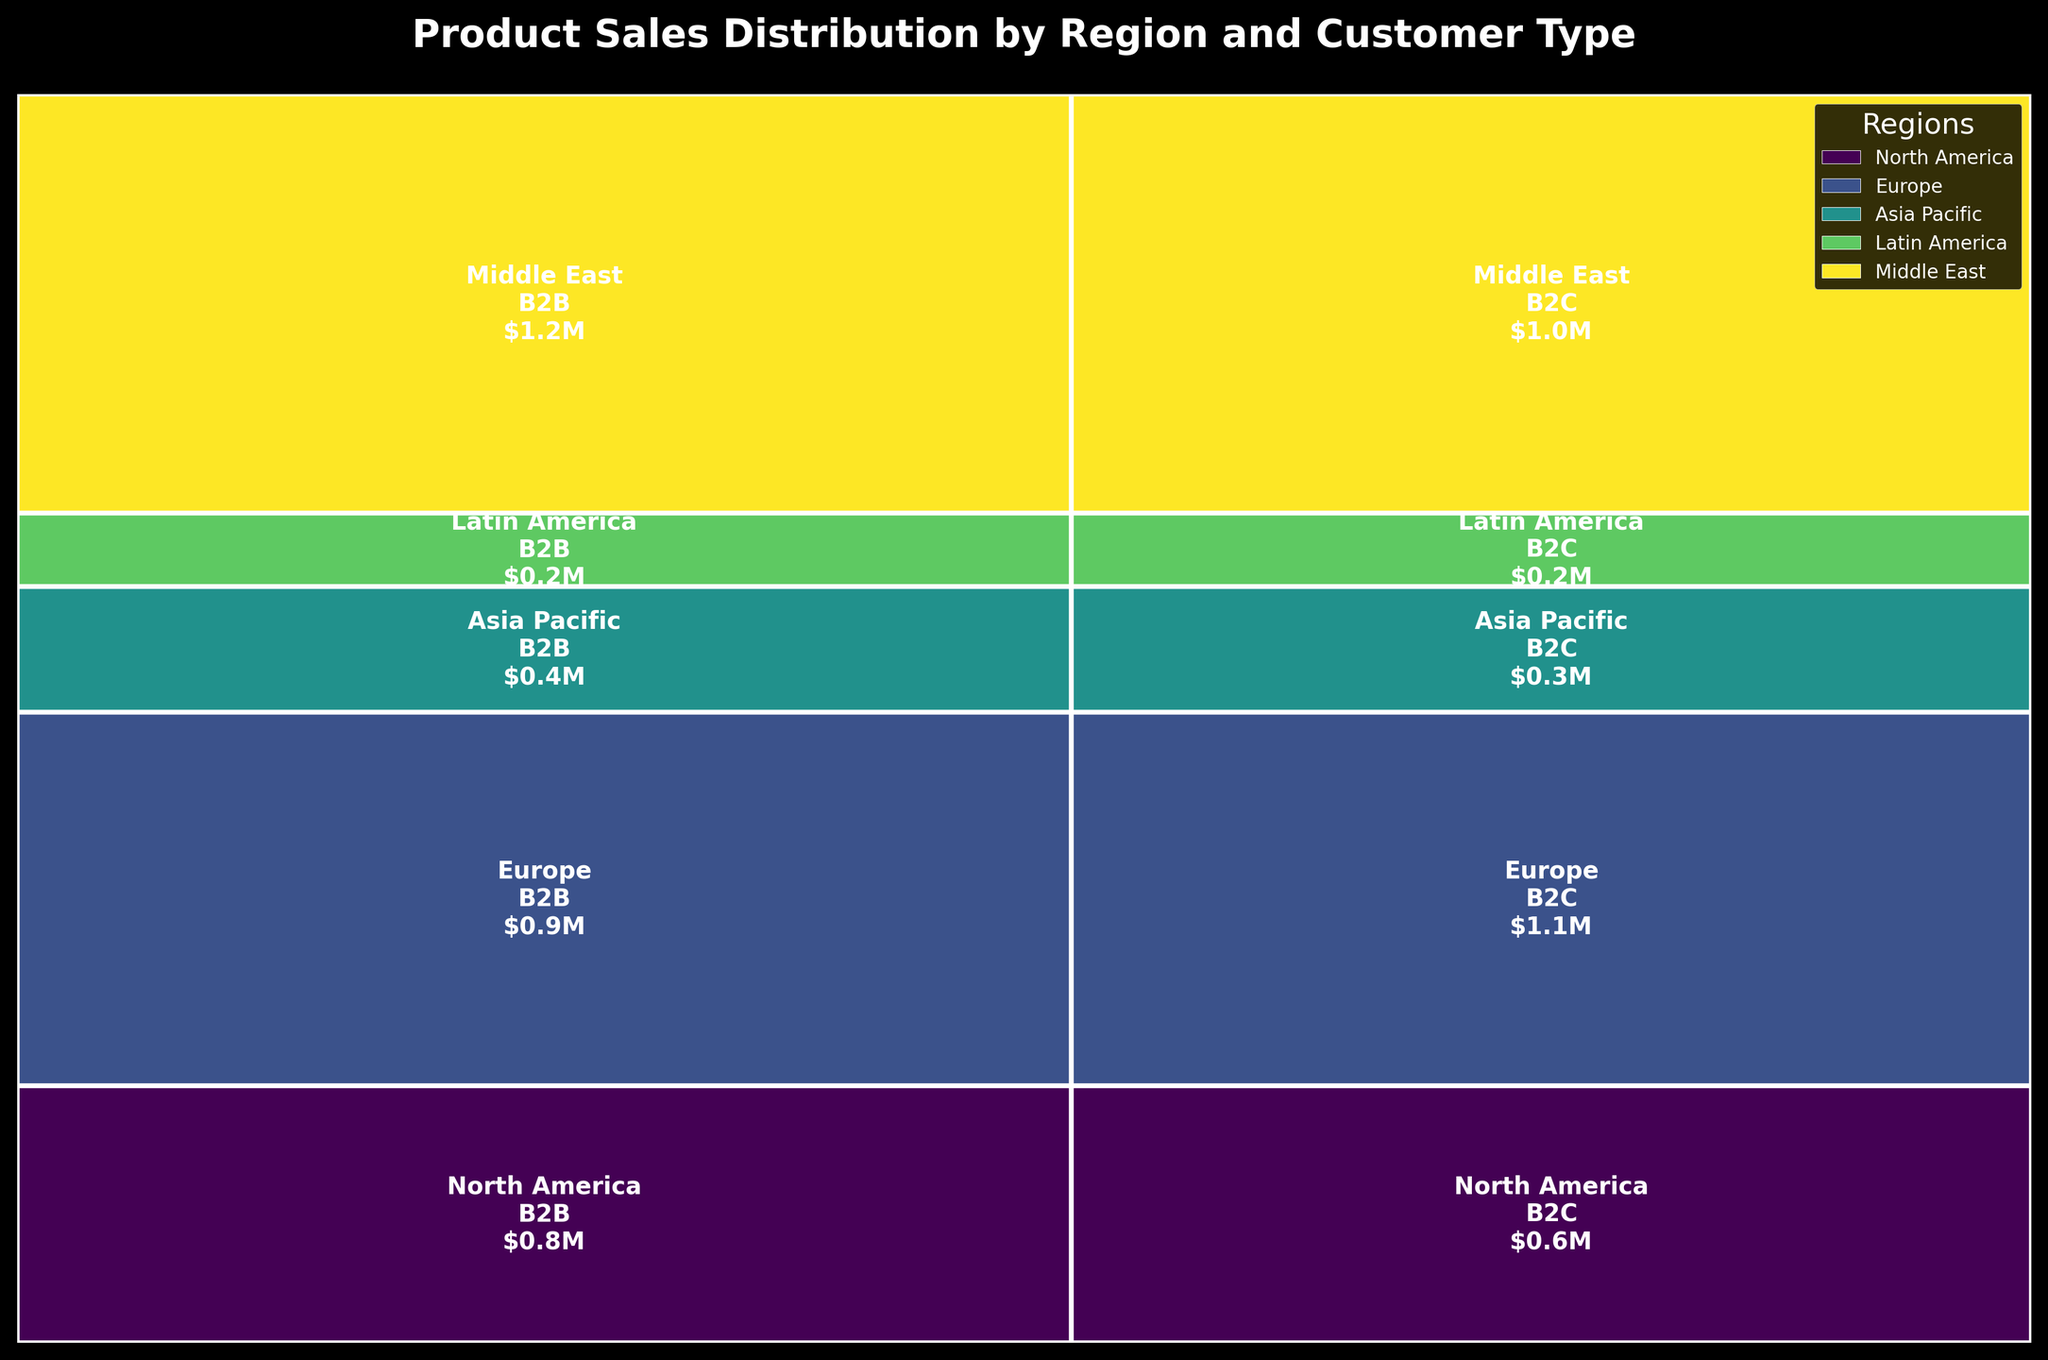What is the title of the figure? The title of the figure is typically placed at the top center of the plot and generally describes the main idea presented within the plot. The title in the figure is "Product Sales Distribution by Region and Customer Type".
Answer: Product Sales Distribution by Region and Customer Type Which region has the largest area represented in the plot? To determine the largest area, observe the height and width of the regions' sections. Europe, B2C has the largest area due to a combination of high sales and large proportions.
Answer: Europe Which customer type has higher sales overall, B2B or B2C? By comparing the total sales for each customer type across all regions, B2B and B2C sections can be summed up visually. B2C has higher sales overall as larger area contributions are seen in B2C sections.
Answer: B2C How much are the sales in North America for B2B customers? The sales amount for North America B2B section is displayed within the respective mosaic section. It states $1.25M (million dollars).
Answer: $1.25M What proportion of total sales does the Asia Pacific region contribute? The contributing proportion is shown by the height of Asia Pacific sections compared to the plot's total height. Asia Pacific contributes approximately (750K + 620K) / 8,820K = 15.53%.
Answer: 15.53% Which region has the smallest contribution to total sales? Comparing the heights of each region, Middle East sections appear to be the smallest in contribution.
Answer: Middle East What is the difference in sales between B2B and B2C in Europe? The sales in Europe for B2B is $0.89M and for B2C is $1.1M. The difference can be calculated as $1.1M - $0.89M = $0.21M.
Answer: $0.21M Between North America and Latin America, which customer type has a larger difference in sales? Compare sales differences for both B2B and B2C types between the two regions. For B2B, the difference is (1.25M - 0.38M = 0.87M), and for B2C, the difference is (0.98M - 0.29M = 0.69M). The B2B customer type shows the larger difference.
Answer: B2B Which region has almost similar sales between B2B and B2C customer types? By examining the sales figures for both B2B and B2C within each region, Middle East shows the smallest difference with $0.21M for B2B and $0.18M for B2C.
Answer: Middle East How does the height of the rectangle for Latin America indicate its sales contribution? The height indicates the sales contribution relative to the total sales, with taller heights showing larger contributions. Latin America has moderately smaller heights, indicating lower sales contributions.
Answer: Lower sales contributions 